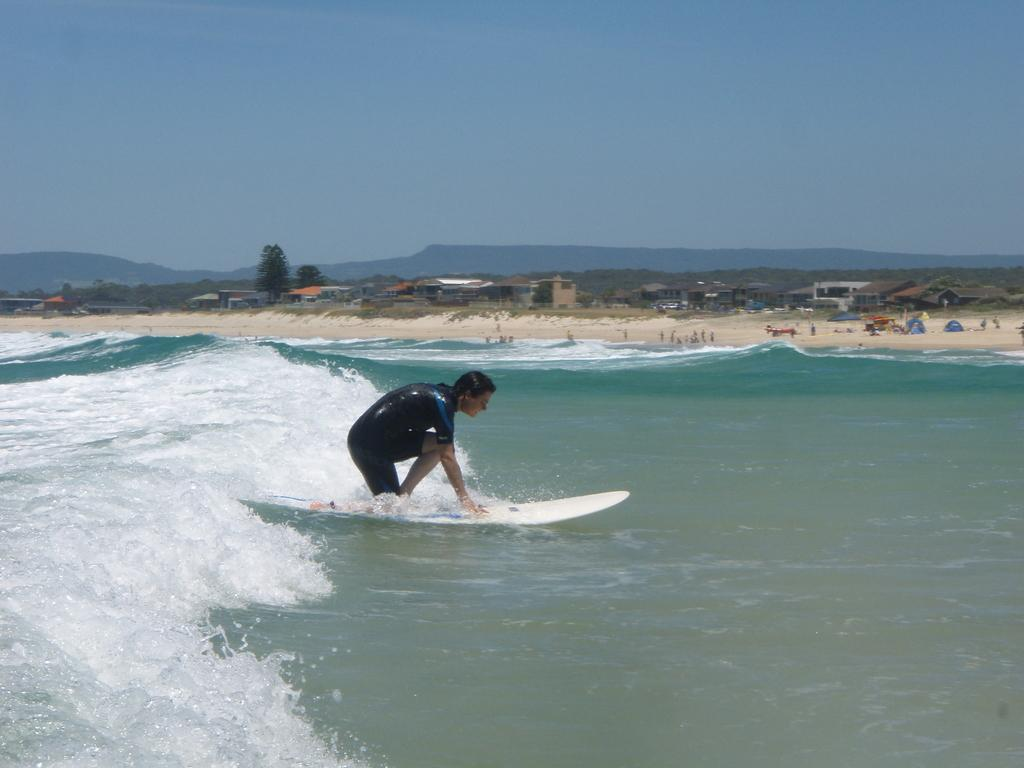What is the man in the image doing? The man is surfing with a surfboard. What is the location of the surfing activity? The surfing is taking place on water. What can be seen in the background of the image? There are houses, trees, hills, and the sky visible in the background of the image. What type of food is the man eating while surfing in the image? There is no food present in the image; the man is surfing with a surfboard. How quiet is the environment in the image? The question of quietness cannot be answered definitively from the image, as there is no information provided about the noise level or ambient sounds. 